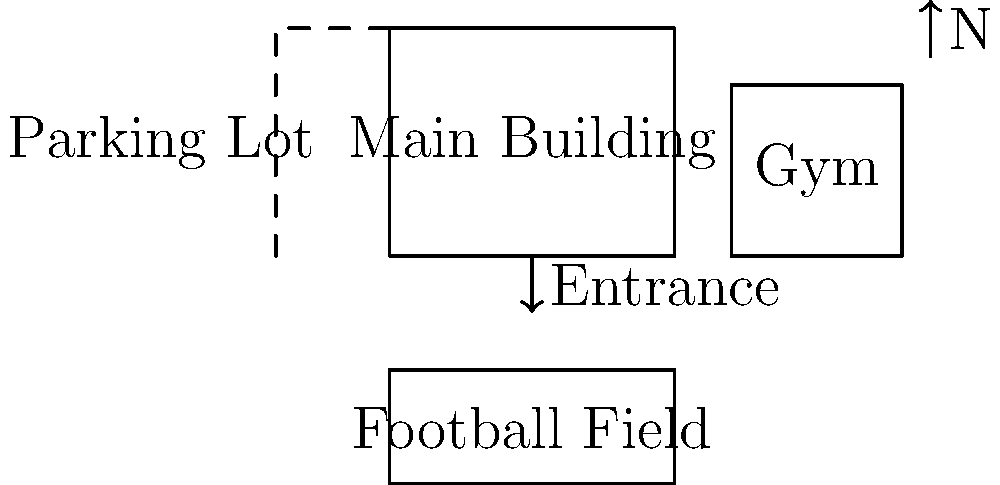Based on the simplified map of Fort Scott High School campus, in which direction would you walk from the main entrance to reach the gymnasium? Let's analyze the map step-by-step:

1. The main entrance is shown at the bottom of the main building, indicated by an arrow.
2. The gymnasium (labeled "Gym") is located to the right of the main building.
3. The north arrow on the map indicates that the top of the map is north.

Given this information:
- To go from the main entrance to the gymnasium, you would need to walk to the right.
- In terms of cardinal directions, walking to the right on this map means moving eastward.

Therefore, from the main entrance, you would walk east to reach the gymnasium.
Answer: East 